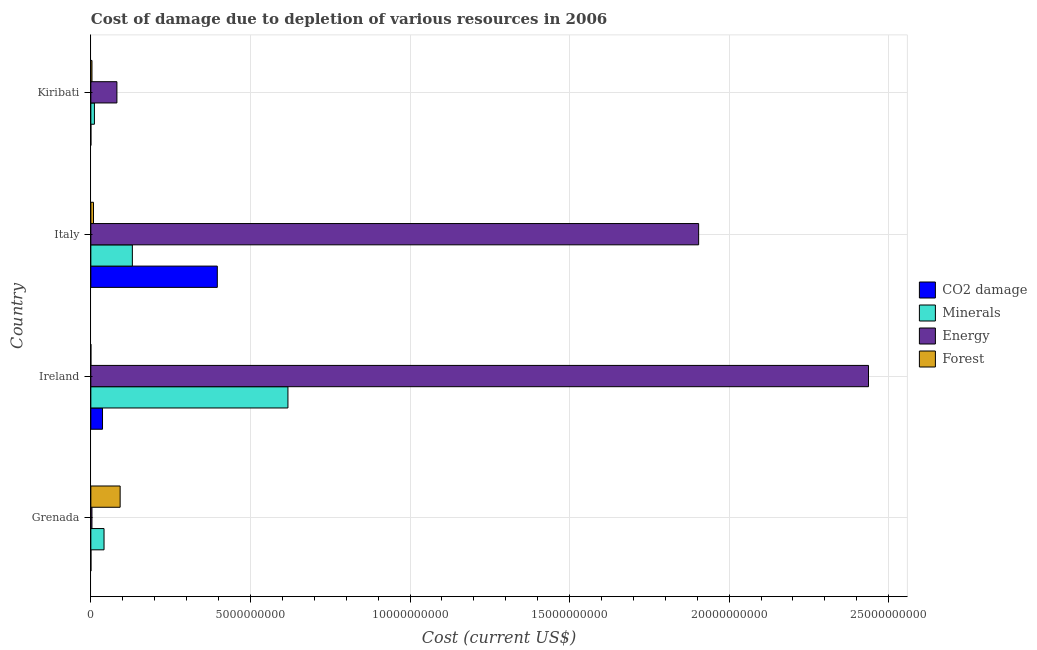Are the number of bars per tick equal to the number of legend labels?
Give a very brief answer. Yes. How many bars are there on the 1st tick from the top?
Ensure brevity in your answer.  4. How many bars are there on the 1st tick from the bottom?
Provide a short and direct response. 4. What is the label of the 3rd group of bars from the top?
Provide a succinct answer. Ireland. In how many cases, is the number of bars for a given country not equal to the number of legend labels?
Give a very brief answer. 0. What is the cost of damage due to depletion of coal in Kiribati?
Keep it short and to the point. 5.88e+05. Across all countries, what is the maximum cost of damage due to depletion of coal?
Provide a succinct answer. 3.96e+09. Across all countries, what is the minimum cost of damage due to depletion of coal?
Give a very brief answer. 5.88e+05. In which country was the cost of damage due to depletion of minerals maximum?
Make the answer very short. Ireland. In which country was the cost of damage due to depletion of minerals minimum?
Your answer should be compact. Kiribati. What is the total cost of damage due to depletion of coal in the graph?
Offer a very short reply. 4.33e+09. What is the difference between the cost of damage due to depletion of energy in Grenada and that in Italy?
Your response must be concise. -1.90e+1. What is the difference between the cost of damage due to depletion of energy in Grenada and the cost of damage due to depletion of minerals in Ireland?
Make the answer very short. -6.14e+09. What is the average cost of damage due to depletion of coal per country?
Offer a very short reply. 1.08e+09. What is the difference between the cost of damage due to depletion of coal and cost of damage due to depletion of minerals in Italy?
Your answer should be compact. 2.66e+09. In how many countries, is the cost of damage due to depletion of minerals greater than 18000000000 US$?
Your answer should be compact. 0. What is the ratio of the cost of damage due to depletion of minerals in Ireland to that in Kiribati?
Your answer should be very brief. 55.16. Is the cost of damage due to depletion of forests in Grenada less than that in Ireland?
Give a very brief answer. No. What is the difference between the highest and the second highest cost of damage due to depletion of forests?
Keep it short and to the point. 8.35e+08. What is the difference between the highest and the lowest cost of damage due to depletion of energy?
Make the answer very short. 2.43e+1. In how many countries, is the cost of damage due to depletion of forests greater than the average cost of damage due to depletion of forests taken over all countries?
Provide a succinct answer. 1. What does the 1st bar from the top in Kiribati represents?
Provide a short and direct response. Forest. What does the 1st bar from the bottom in Kiribati represents?
Your answer should be very brief. CO2 damage. Is it the case that in every country, the sum of the cost of damage due to depletion of coal and cost of damage due to depletion of minerals is greater than the cost of damage due to depletion of energy?
Ensure brevity in your answer.  No. How many bars are there?
Keep it short and to the point. 16. Are all the bars in the graph horizontal?
Offer a very short reply. Yes. How many countries are there in the graph?
Provide a succinct answer. 4. What is the difference between two consecutive major ticks on the X-axis?
Provide a succinct answer. 5.00e+09. Are the values on the major ticks of X-axis written in scientific E-notation?
Your answer should be compact. No. How many legend labels are there?
Provide a succinct answer. 4. How are the legend labels stacked?
Provide a succinct answer. Vertical. What is the title of the graph?
Offer a terse response. Cost of damage due to depletion of various resources in 2006 . Does "Industry" appear as one of the legend labels in the graph?
Make the answer very short. No. What is the label or title of the X-axis?
Offer a very short reply. Cost (current US$). What is the Cost (current US$) of CO2 damage in Grenada?
Your answer should be very brief. 1.95e+06. What is the Cost (current US$) in Minerals in Grenada?
Offer a very short reply. 4.13e+08. What is the Cost (current US$) in Energy in Grenada?
Offer a very short reply. 3.48e+07. What is the Cost (current US$) of Forest in Grenada?
Your answer should be compact. 9.18e+08. What is the Cost (current US$) of CO2 damage in Ireland?
Offer a terse response. 3.65e+08. What is the Cost (current US$) in Minerals in Ireland?
Make the answer very short. 6.18e+09. What is the Cost (current US$) in Energy in Ireland?
Your response must be concise. 2.44e+1. What is the Cost (current US$) in Forest in Ireland?
Your answer should be compact. 4.88e+05. What is the Cost (current US$) in CO2 damage in Italy?
Offer a very short reply. 3.96e+09. What is the Cost (current US$) in Minerals in Italy?
Make the answer very short. 1.30e+09. What is the Cost (current US$) in Energy in Italy?
Provide a succinct answer. 1.90e+1. What is the Cost (current US$) in Forest in Italy?
Offer a very short reply. 8.31e+07. What is the Cost (current US$) in CO2 damage in Kiribati?
Offer a terse response. 5.88e+05. What is the Cost (current US$) in Minerals in Kiribati?
Keep it short and to the point. 1.12e+08. What is the Cost (current US$) in Energy in Kiribati?
Your response must be concise. 8.17e+08. What is the Cost (current US$) in Forest in Kiribati?
Your answer should be compact. 3.49e+07. Across all countries, what is the maximum Cost (current US$) in CO2 damage?
Provide a succinct answer. 3.96e+09. Across all countries, what is the maximum Cost (current US$) in Minerals?
Your response must be concise. 6.18e+09. Across all countries, what is the maximum Cost (current US$) of Energy?
Ensure brevity in your answer.  2.44e+1. Across all countries, what is the maximum Cost (current US$) in Forest?
Provide a succinct answer. 9.18e+08. Across all countries, what is the minimum Cost (current US$) in CO2 damage?
Your answer should be very brief. 5.88e+05. Across all countries, what is the minimum Cost (current US$) in Minerals?
Offer a terse response. 1.12e+08. Across all countries, what is the minimum Cost (current US$) in Energy?
Keep it short and to the point. 3.48e+07. Across all countries, what is the minimum Cost (current US$) in Forest?
Your answer should be very brief. 4.88e+05. What is the total Cost (current US$) in CO2 damage in the graph?
Your answer should be compact. 4.33e+09. What is the total Cost (current US$) of Minerals in the graph?
Make the answer very short. 8.00e+09. What is the total Cost (current US$) of Energy in the graph?
Offer a very short reply. 4.43e+1. What is the total Cost (current US$) in Forest in the graph?
Give a very brief answer. 1.04e+09. What is the difference between the Cost (current US$) in CO2 damage in Grenada and that in Ireland?
Your response must be concise. -3.64e+08. What is the difference between the Cost (current US$) of Minerals in Grenada and that in Ireland?
Ensure brevity in your answer.  -5.76e+09. What is the difference between the Cost (current US$) in Energy in Grenada and that in Ireland?
Provide a short and direct response. -2.43e+1. What is the difference between the Cost (current US$) in Forest in Grenada and that in Ireland?
Make the answer very short. 9.18e+08. What is the difference between the Cost (current US$) in CO2 damage in Grenada and that in Italy?
Ensure brevity in your answer.  -3.96e+09. What is the difference between the Cost (current US$) in Minerals in Grenada and that in Italy?
Keep it short and to the point. -8.88e+08. What is the difference between the Cost (current US$) in Energy in Grenada and that in Italy?
Provide a succinct answer. -1.90e+1. What is the difference between the Cost (current US$) of Forest in Grenada and that in Italy?
Your answer should be very brief. 8.35e+08. What is the difference between the Cost (current US$) of CO2 damage in Grenada and that in Kiribati?
Offer a terse response. 1.36e+06. What is the difference between the Cost (current US$) in Minerals in Grenada and that in Kiribati?
Offer a terse response. 3.01e+08. What is the difference between the Cost (current US$) in Energy in Grenada and that in Kiribati?
Ensure brevity in your answer.  -7.82e+08. What is the difference between the Cost (current US$) in Forest in Grenada and that in Kiribati?
Give a very brief answer. 8.83e+08. What is the difference between the Cost (current US$) in CO2 damage in Ireland and that in Italy?
Provide a short and direct response. -3.60e+09. What is the difference between the Cost (current US$) of Minerals in Ireland and that in Italy?
Give a very brief answer. 4.87e+09. What is the difference between the Cost (current US$) in Energy in Ireland and that in Italy?
Offer a very short reply. 5.32e+09. What is the difference between the Cost (current US$) in Forest in Ireland and that in Italy?
Make the answer very short. -8.26e+07. What is the difference between the Cost (current US$) of CO2 damage in Ireland and that in Kiribati?
Give a very brief answer. 3.65e+08. What is the difference between the Cost (current US$) of Minerals in Ireland and that in Kiribati?
Offer a very short reply. 6.06e+09. What is the difference between the Cost (current US$) in Energy in Ireland and that in Kiribati?
Keep it short and to the point. 2.35e+1. What is the difference between the Cost (current US$) in Forest in Ireland and that in Kiribati?
Offer a very short reply. -3.45e+07. What is the difference between the Cost (current US$) of CO2 damage in Italy and that in Kiribati?
Keep it short and to the point. 3.96e+09. What is the difference between the Cost (current US$) in Minerals in Italy and that in Kiribati?
Offer a terse response. 1.19e+09. What is the difference between the Cost (current US$) of Energy in Italy and that in Kiribati?
Give a very brief answer. 1.82e+1. What is the difference between the Cost (current US$) of Forest in Italy and that in Kiribati?
Provide a succinct answer. 4.81e+07. What is the difference between the Cost (current US$) in CO2 damage in Grenada and the Cost (current US$) in Minerals in Ireland?
Your answer should be very brief. -6.17e+09. What is the difference between the Cost (current US$) in CO2 damage in Grenada and the Cost (current US$) in Energy in Ireland?
Your answer should be compact. -2.44e+1. What is the difference between the Cost (current US$) of CO2 damage in Grenada and the Cost (current US$) of Forest in Ireland?
Your response must be concise. 1.46e+06. What is the difference between the Cost (current US$) in Minerals in Grenada and the Cost (current US$) in Energy in Ireland?
Provide a short and direct response. -2.40e+1. What is the difference between the Cost (current US$) of Minerals in Grenada and the Cost (current US$) of Forest in Ireland?
Offer a very short reply. 4.13e+08. What is the difference between the Cost (current US$) of Energy in Grenada and the Cost (current US$) of Forest in Ireland?
Your response must be concise. 3.43e+07. What is the difference between the Cost (current US$) of CO2 damage in Grenada and the Cost (current US$) of Minerals in Italy?
Your answer should be compact. -1.30e+09. What is the difference between the Cost (current US$) of CO2 damage in Grenada and the Cost (current US$) of Energy in Italy?
Make the answer very short. -1.90e+1. What is the difference between the Cost (current US$) in CO2 damage in Grenada and the Cost (current US$) in Forest in Italy?
Your answer should be compact. -8.11e+07. What is the difference between the Cost (current US$) of Minerals in Grenada and the Cost (current US$) of Energy in Italy?
Keep it short and to the point. -1.86e+1. What is the difference between the Cost (current US$) of Minerals in Grenada and the Cost (current US$) of Forest in Italy?
Offer a terse response. 3.30e+08. What is the difference between the Cost (current US$) of Energy in Grenada and the Cost (current US$) of Forest in Italy?
Offer a very short reply. -4.83e+07. What is the difference between the Cost (current US$) in CO2 damage in Grenada and the Cost (current US$) in Minerals in Kiribati?
Your answer should be very brief. -1.10e+08. What is the difference between the Cost (current US$) of CO2 damage in Grenada and the Cost (current US$) of Energy in Kiribati?
Provide a succinct answer. -8.15e+08. What is the difference between the Cost (current US$) in CO2 damage in Grenada and the Cost (current US$) in Forest in Kiribati?
Offer a very short reply. -3.30e+07. What is the difference between the Cost (current US$) of Minerals in Grenada and the Cost (current US$) of Energy in Kiribati?
Provide a short and direct response. -4.04e+08. What is the difference between the Cost (current US$) of Minerals in Grenada and the Cost (current US$) of Forest in Kiribati?
Make the answer very short. 3.78e+08. What is the difference between the Cost (current US$) in Energy in Grenada and the Cost (current US$) in Forest in Kiribati?
Your response must be concise. -1.87e+05. What is the difference between the Cost (current US$) in CO2 damage in Ireland and the Cost (current US$) in Minerals in Italy?
Your response must be concise. -9.35e+08. What is the difference between the Cost (current US$) of CO2 damage in Ireland and the Cost (current US$) of Energy in Italy?
Keep it short and to the point. -1.87e+1. What is the difference between the Cost (current US$) in CO2 damage in Ireland and the Cost (current US$) in Forest in Italy?
Give a very brief answer. 2.82e+08. What is the difference between the Cost (current US$) in Minerals in Ireland and the Cost (current US$) in Energy in Italy?
Offer a terse response. -1.29e+1. What is the difference between the Cost (current US$) of Minerals in Ireland and the Cost (current US$) of Forest in Italy?
Your answer should be compact. 6.09e+09. What is the difference between the Cost (current US$) in Energy in Ireland and the Cost (current US$) in Forest in Italy?
Offer a very short reply. 2.43e+1. What is the difference between the Cost (current US$) of CO2 damage in Ireland and the Cost (current US$) of Minerals in Kiribati?
Offer a very short reply. 2.54e+08. What is the difference between the Cost (current US$) in CO2 damage in Ireland and the Cost (current US$) in Energy in Kiribati?
Offer a terse response. -4.51e+08. What is the difference between the Cost (current US$) in CO2 damage in Ireland and the Cost (current US$) in Forest in Kiribati?
Offer a terse response. 3.31e+08. What is the difference between the Cost (current US$) of Minerals in Ireland and the Cost (current US$) of Energy in Kiribati?
Make the answer very short. 5.36e+09. What is the difference between the Cost (current US$) of Minerals in Ireland and the Cost (current US$) of Forest in Kiribati?
Keep it short and to the point. 6.14e+09. What is the difference between the Cost (current US$) of Energy in Ireland and the Cost (current US$) of Forest in Kiribati?
Ensure brevity in your answer.  2.43e+1. What is the difference between the Cost (current US$) in CO2 damage in Italy and the Cost (current US$) in Minerals in Kiribati?
Give a very brief answer. 3.85e+09. What is the difference between the Cost (current US$) of CO2 damage in Italy and the Cost (current US$) of Energy in Kiribati?
Keep it short and to the point. 3.15e+09. What is the difference between the Cost (current US$) of CO2 damage in Italy and the Cost (current US$) of Forest in Kiribati?
Your answer should be very brief. 3.93e+09. What is the difference between the Cost (current US$) of Minerals in Italy and the Cost (current US$) of Energy in Kiribati?
Your response must be concise. 4.84e+08. What is the difference between the Cost (current US$) in Minerals in Italy and the Cost (current US$) in Forest in Kiribati?
Offer a very short reply. 1.27e+09. What is the difference between the Cost (current US$) of Energy in Italy and the Cost (current US$) of Forest in Kiribati?
Offer a terse response. 1.90e+1. What is the average Cost (current US$) in CO2 damage per country?
Your answer should be very brief. 1.08e+09. What is the average Cost (current US$) in Minerals per country?
Provide a short and direct response. 2.00e+09. What is the average Cost (current US$) in Energy per country?
Offer a terse response. 1.11e+1. What is the average Cost (current US$) in Forest per country?
Your response must be concise. 2.59e+08. What is the difference between the Cost (current US$) of CO2 damage and Cost (current US$) of Minerals in Grenada?
Offer a terse response. -4.11e+08. What is the difference between the Cost (current US$) of CO2 damage and Cost (current US$) of Energy in Grenada?
Your answer should be very brief. -3.28e+07. What is the difference between the Cost (current US$) in CO2 damage and Cost (current US$) in Forest in Grenada?
Ensure brevity in your answer.  -9.16e+08. What is the difference between the Cost (current US$) of Minerals and Cost (current US$) of Energy in Grenada?
Ensure brevity in your answer.  3.78e+08. What is the difference between the Cost (current US$) in Minerals and Cost (current US$) in Forest in Grenada?
Your response must be concise. -5.05e+08. What is the difference between the Cost (current US$) in Energy and Cost (current US$) in Forest in Grenada?
Keep it short and to the point. -8.83e+08. What is the difference between the Cost (current US$) of CO2 damage and Cost (current US$) of Minerals in Ireland?
Offer a very short reply. -5.81e+09. What is the difference between the Cost (current US$) of CO2 damage and Cost (current US$) of Energy in Ireland?
Ensure brevity in your answer.  -2.40e+1. What is the difference between the Cost (current US$) of CO2 damage and Cost (current US$) of Forest in Ireland?
Your answer should be compact. 3.65e+08. What is the difference between the Cost (current US$) of Minerals and Cost (current US$) of Energy in Ireland?
Keep it short and to the point. -1.82e+1. What is the difference between the Cost (current US$) of Minerals and Cost (current US$) of Forest in Ireland?
Your answer should be very brief. 6.17e+09. What is the difference between the Cost (current US$) in Energy and Cost (current US$) in Forest in Ireland?
Offer a terse response. 2.44e+1. What is the difference between the Cost (current US$) in CO2 damage and Cost (current US$) in Minerals in Italy?
Your response must be concise. 2.66e+09. What is the difference between the Cost (current US$) in CO2 damage and Cost (current US$) in Energy in Italy?
Keep it short and to the point. -1.51e+1. What is the difference between the Cost (current US$) in CO2 damage and Cost (current US$) in Forest in Italy?
Make the answer very short. 3.88e+09. What is the difference between the Cost (current US$) in Minerals and Cost (current US$) in Energy in Italy?
Keep it short and to the point. -1.77e+1. What is the difference between the Cost (current US$) of Minerals and Cost (current US$) of Forest in Italy?
Make the answer very short. 1.22e+09. What is the difference between the Cost (current US$) in Energy and Cost (current US$) in Forest in Italy?
Keep it short and to the point. 1.90e+1. What is the difference between the Cost (current US$) of CO2 damage and Cost (current US$) of Minerals in Kiribati?
Make the answer very short. -1.11e+08. What is the difference between the Cost (current US$) in CO2 damage and Cost (current US$) in Energy in Kiribati?
Give a very brief answer. -8.16e+08. What is the difference between the Cost (current US$) of CO2 damage and Cost (current US$) of Forest in Kiribati?
Provide a succinct answer. -3.44e+07. What is the difference between the Cost (current US$) in Minerals and Cost (current US$) in Energy in Kiribati?
Provide a short and direct response. -7.05e+08. What is the difference between the Cost (current US$) of Minerals and Cost (current US$) of Forest in Kiribati?
Your response must be concise. 7.70e+07. What is the difference between the Cost (current US$) in Energy and Cost (current US$) in Forest in Kiribati?
Your answer should be very brief. 7.82e+08. What is the ratio of the Cost (current US$) of CO2 damage in Grenada to that in Ireland?
Make the answer very short. 0.01. What is the ratio of the Cost (current US$) of Minerals in Grenada to that in Ireland?
Provide a short and direct response. 0.07. What is the ratio of the Cost (current US$) of Energy in Grenada to that in Ireland?
Provide a short and direct response. 0. What is the ratio of the Cost (current US$) of Forest in Grenada to that in Ireland?
Make the answer very short. 1882.58. What is the ratio of the Cost (current US$) in CO2 damage in Grenada to that in Italy?
Provide a succinct answer. 0. What is the ratio of the Cost (current US$) of Minerals in Grenada to that in Italy?
Offer a very short reply. 0.32. What is the ratio of the Cost (current US$) in Energy in Grenada to that in Italy?
Make the answer very short. 0. What is the ratio of the Cost (current US$) in Forest in Grenada to that in Italy?
Provide a succinct answer. 11.05. What is the ratio of the Cost (current US$) of CO2 damage in Grenada to that in Kiribati?
Give a very brief answer. 3.32. What is the ratio of the Cost (current US$) of Minerals in Grenada to that in Kiribati?
Keep it short and to the point. 3.69. What is the ratio of the Cost (current US$) in Energy in Grenada to that in Kiribati?
Keep it short and to the point. 0.04. What is the ratio of the Cost (current US$) of Forest in Grenada to that in Kiribati?
Provide a short and direct response. 26.27. What is the ratio of the Cost (current US$) in CO2 damage in Ireland to that in Italy?
Ensure brevity in your answer.  0.09. What is the ratio of the Cost (current US$) of Minerals in Ireland to that in Italy?
Ensure brevity in your answer.  4.75. What is the ratio of the Cost (current US$) of Energy in Ireland to that in Italy?
Your response must be concise. 1.28. What is the ratio of the Cost (current US$) in Forest in Ireland to that in Italy?
Provide a succinct answer. 0.01. What is the ratio of the Cost (current US$) of CO2 damage in Ireland to that in Kiribati?
Your answer should be very brief. 621.37. What is the ratio of the Cost (current US$) in Minerals in Ireland to that in Kiribati?
Offer a terse response. 55.16. What is the ratio of the Cost (current US$) of Energy in Ireland to that in Kiribati?
Offer a terse response. 29.83. What is the ratio of the Cost (current US$) in Forest in Ireland to that in Kiribati?
Keep it short and to the point. 0.01. What is the ratio of the Cost (current US$) in CO2 damage in Italy to that in Kiribati?
Give a very brief answer. 6736.42. What is the ratio of the Cost (current US$) in Minerals in Italy to that in Kiribati?
Your response must be concise. 11.62. What is the ratio of the Cost (current US$) of Energy in Italy to that in Kiribati?
Ensure brevity in your answer.  23.32. What is the ratio of the Cost (current US$) of Forest in Italy to that in Kiribati?
Ensure brevity in your answer.  2.38. What is the difference between the highest and the second highest Cost (current US$) in CO2 damage?
Give a very brief answer. 3.60e+09. What is the difference between the highest and the second highest Cost (current US$) in Minerals?
Give a very brief answer. 4.87e+09. What is the difference between the highest and the second highest Cost (current US$) in Energy?
Make the answer very short. 5.32e+09. What is the difference between the highest and the second highest Cost (current US$) of Forest?
Offer a terse response. 8.35e+08. What is the difference between the highest and the lowest Cost (current US$) in CO2 damage?
Offer a very short reply. 3.96e+09. What is the difference between the highest and the lowest Cost (current US$) in Minerals?
Offer a very short reply. 6.06e+09. What is the difference between the highest and the lowest Cost (current US$) of Energy?
Provide a short and direct response. 2.43e+1. What is the difference between the highest and the lowest Cost (current US$) of Forest?
Ensure brevity in your answer.  9.18e+08. 